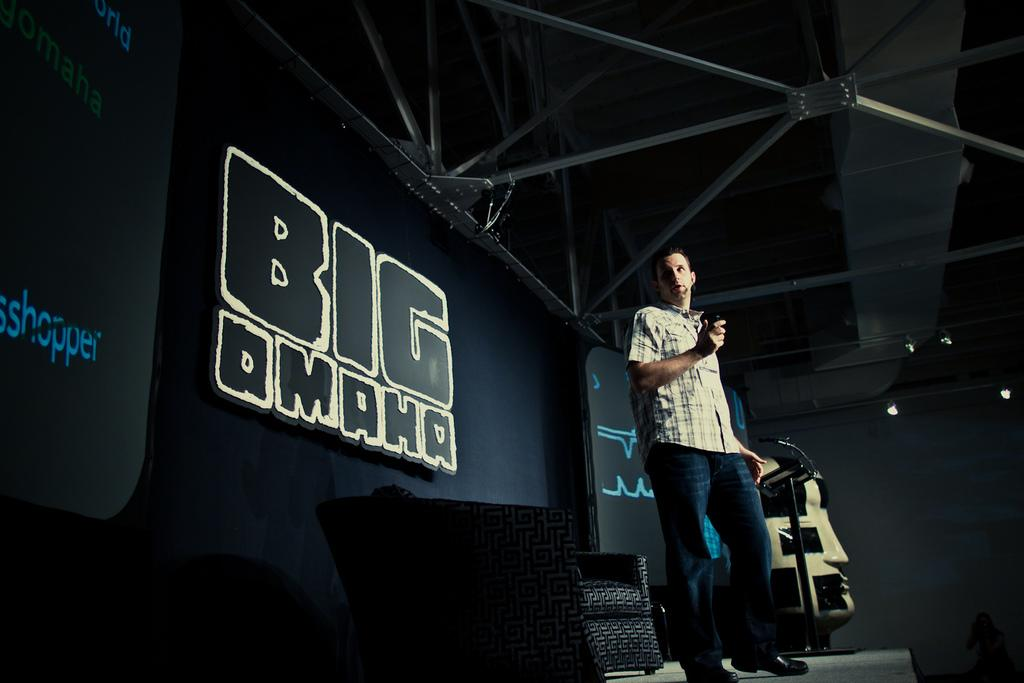What is the main subject in the middle of the image? There is a man standing in the middle of the image. What is located behind the man? There is a chair behind the man. What is behind the chair? There is a screen behind the chair. What can be seen at the top of the image? The top of the image contains a roof and lights. What type of tax is being discussed in the image? There is no discussion of tax in the image; it primarily features a man, a chair, a screen, a roof, and lights. 